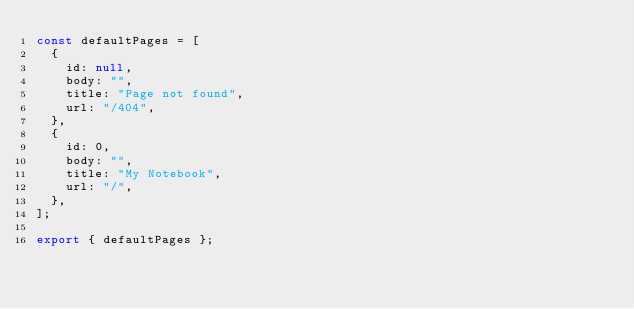<code> <loc_0><loc_0><loc_500><loc_500><_JavaScript_>const defaultPages = [
  {
    id: null,
    body: "",
    title: "Page not found",
    url: "/404",
  },
  {
    id: 0,
    body: "",
    title: "My Notebook",
    url: "/",
  },
];

export { defaultPages };
</code> 